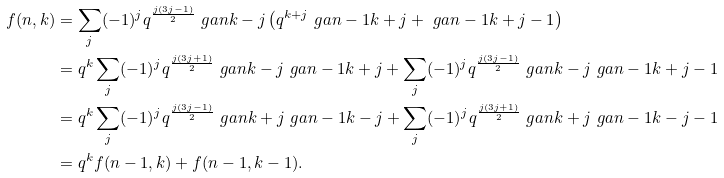Convert formula to latex. <formula><loc_0><loc_0><loc_500><loc_500>f ( n , k ) & = \sum _ { j } ( - 1 ) ^ { j } q ^ { \frac { j ( 3 j - 1 ) } { 2 } } \ g a { n } { k - j } \left ( q ^ { k + j } \ g a { n - 1 } { k + j } + \ g a { n - 1 } { k + j - 1 } \right ) \\ & = q ^ { k } \sum _ { j } ( - 1 ) ^ { j } q ^ { \frac { j ( 3 j + 1 ) } { 2 } } \ g a { n } { k - j } \ g a { n - 1 } { k + j } + \sum _ { j } ( - 1 ) ^ { j } q ^ { \frac { j ( 3 j - 1 ) } { 2 } } \ g a { n } { k - j } \ g a { n - 1 } { k + j - 1 } \\ & = q ^ { k } \sum _ { j } ( - 1 ) ^ { j } q ^ { \frac { j ( 3 j - 1 ) } { 2 } } \ g a { n } { k + j } \ g a { n - 1 } { k - j } + \sum _ { j } ( - 1 ) ^ { j } q ^ { \frac { j ( 3 j + 1 ) } { 2 } } \ g a { n } { k + j } \ g a { n - 1 } { k - j - 1 } \\ & = q ^ { k } f ( n - 1 , k ) + f ( n - 1 , k - 1 ) .</formula> 